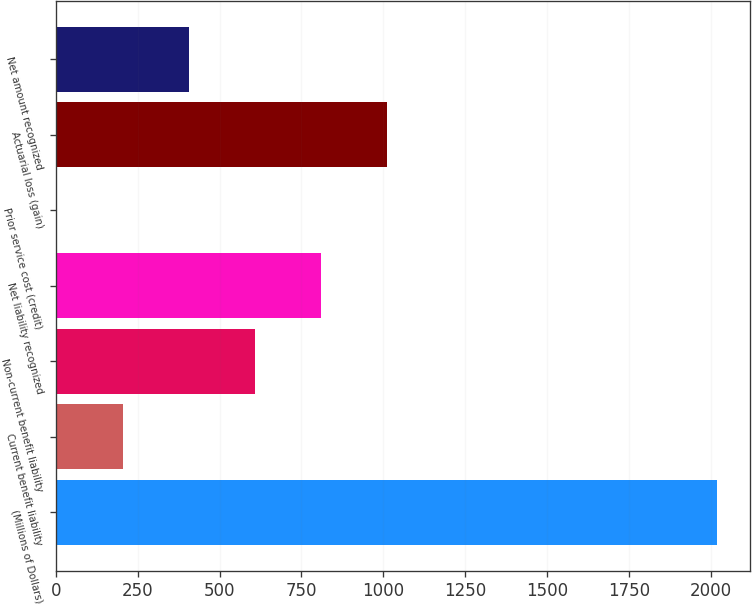Convert chart. <chart><loc_0><loc_0><loc_500><loc_500><bar_chart><fcel>(Millions of Dollars)<fcel>Current benefit liability<fcel>Non-current benefit liability<fcel>Net liability recognized<fcel>Prior service cost (credit)<fcel>Actuarial loss (gain)<fcel>Net amount recognized<nl><fcel>2018<fcel>205.67<fcel>608.41<fcel>809.78<fcel>4.3<fcel>1011.15<fcel>407.04<nl></chart> 